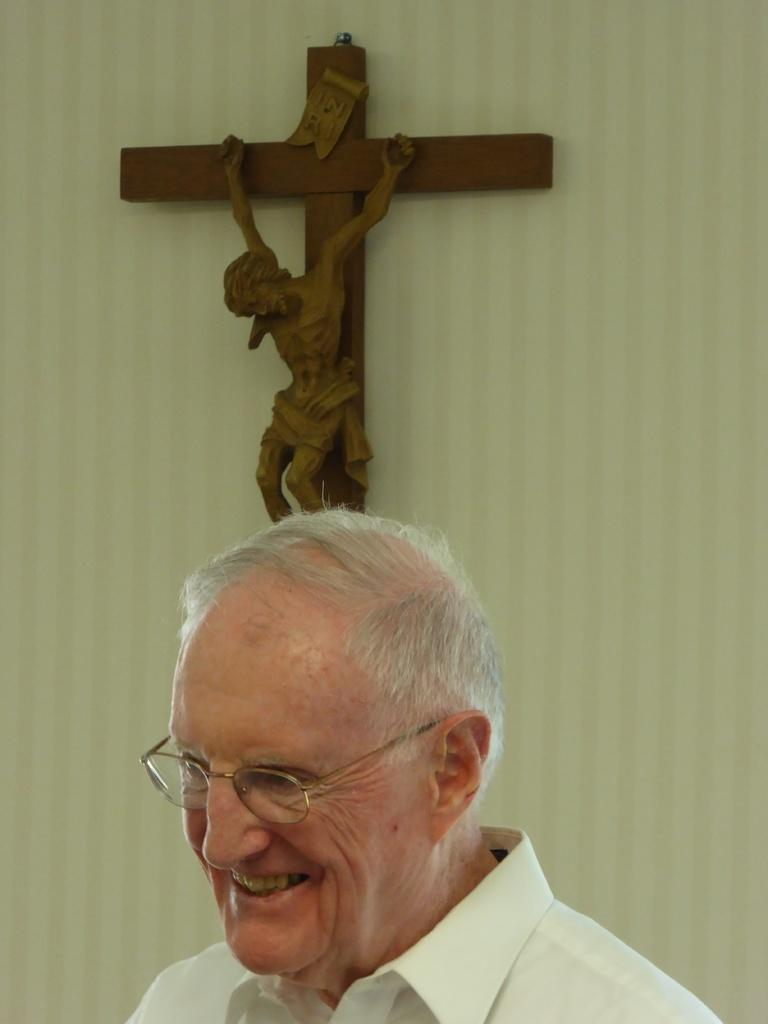Who is present in the image? There is a man in the image. What is the man wearing? The man is wearing spectacles. What is the man's facial expression? The man is smiling. What can be seen on the wall in the background of the image? There is a cross on the wall in the background of the image. What type of star can be seen glowing in the vessel in the image? There is no star or vessel present in the image. 